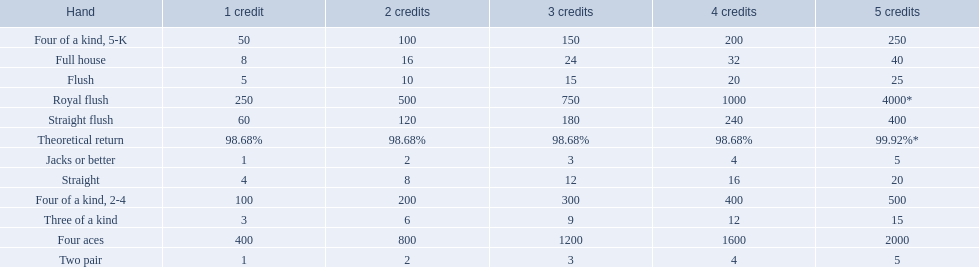What is the higher amount of points for one credit you can get from the best four of a kind 100. What type is it? Four of a kind, 2-4. 